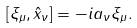Convert formula to latex. <formula><loc_0><loc_0><loc_500><loc_500>[ \xi _ { \mu } , \hat { x } _ { \nu } ] = - i a _ { \nu } \xi _ { \mu } .</formula> 